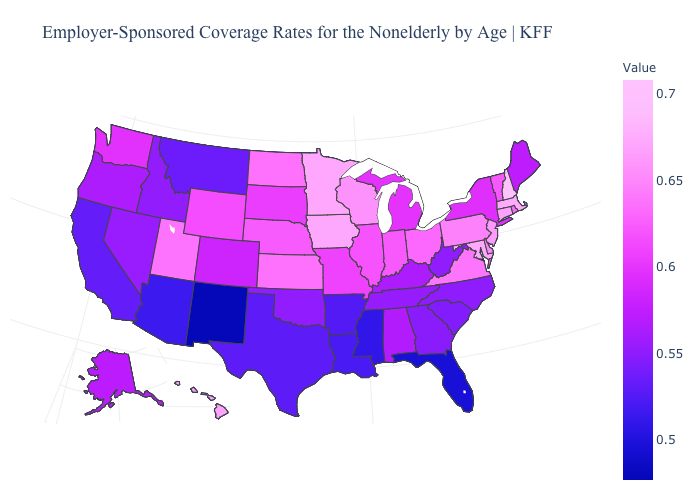Among the states that border Nebraska , which have the highest value?
Quick response, please. Iowa. Does Nevada have the lowest value in the USA?
Keep it brief. No. Does the map have missing data?
Write a very short answer. No. Does Minnesota have a lower value than New Hampshire?
Answer briefly. Yes. 